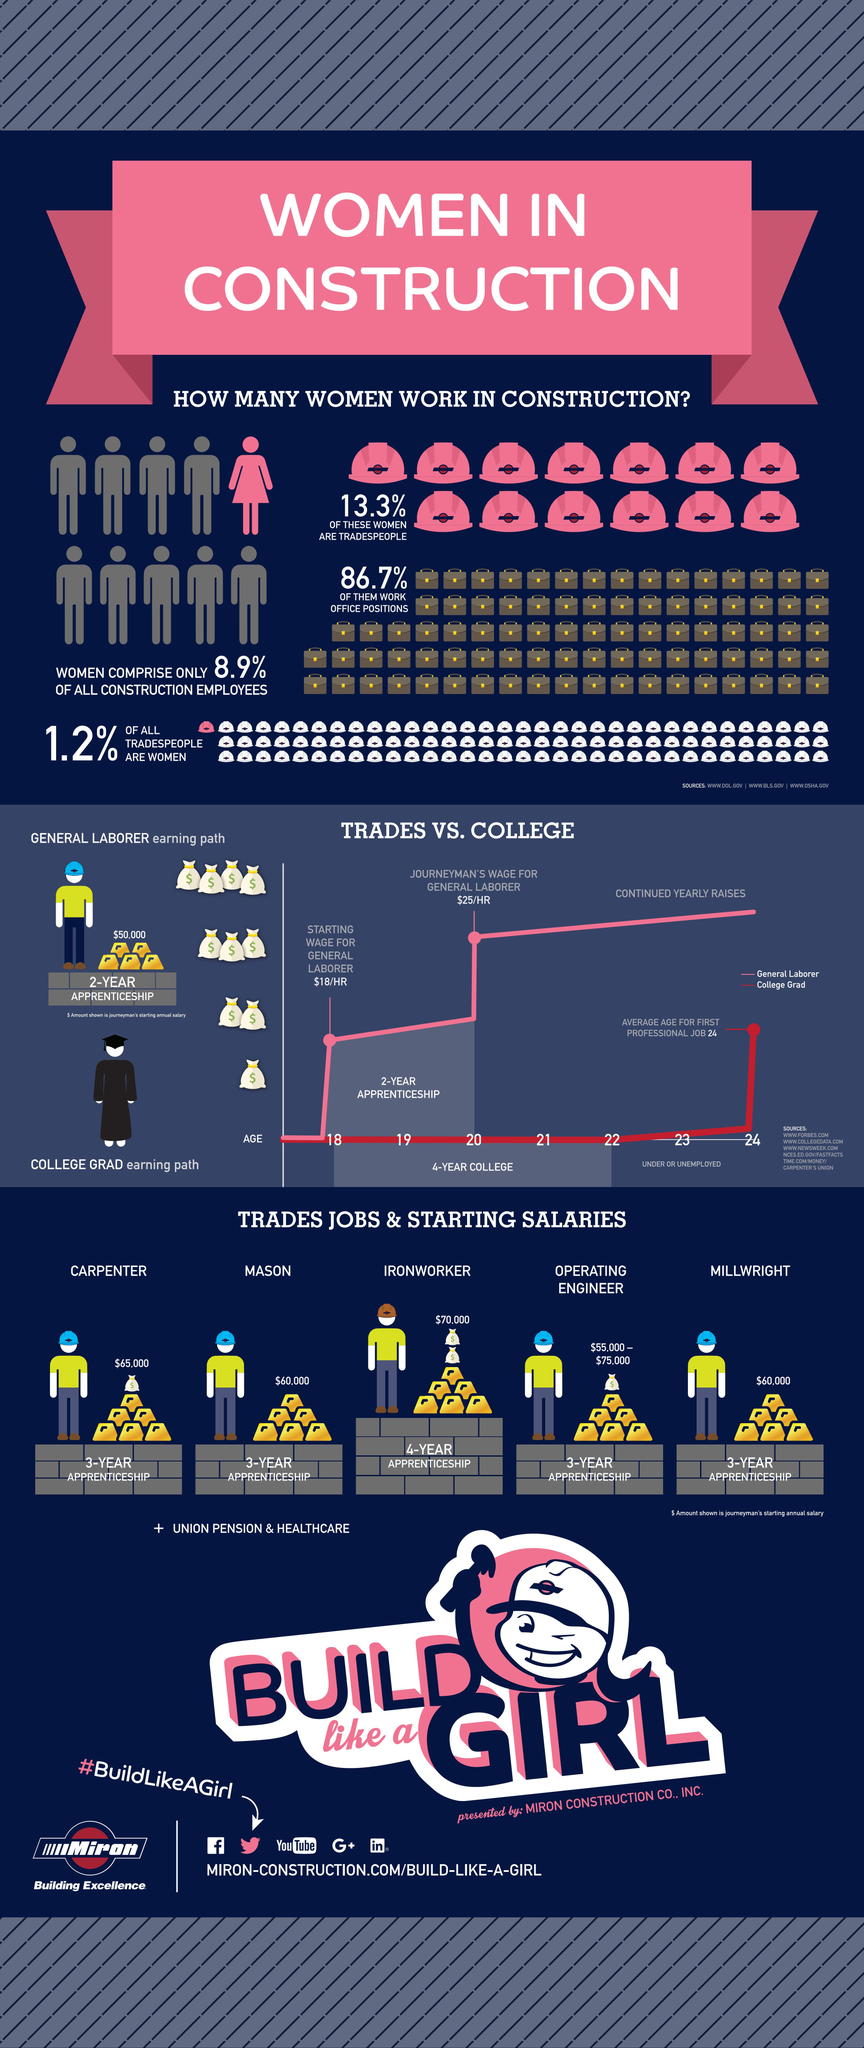Point out several critical features in this image. In the construction field, men held office positions at a rate of 13.3%. The starting annual salary of an ironworker is approximately $70,000. The starting wage for a general labourer is $18 per hour. The starting annual salary of a mason is reported to be $60,000. 